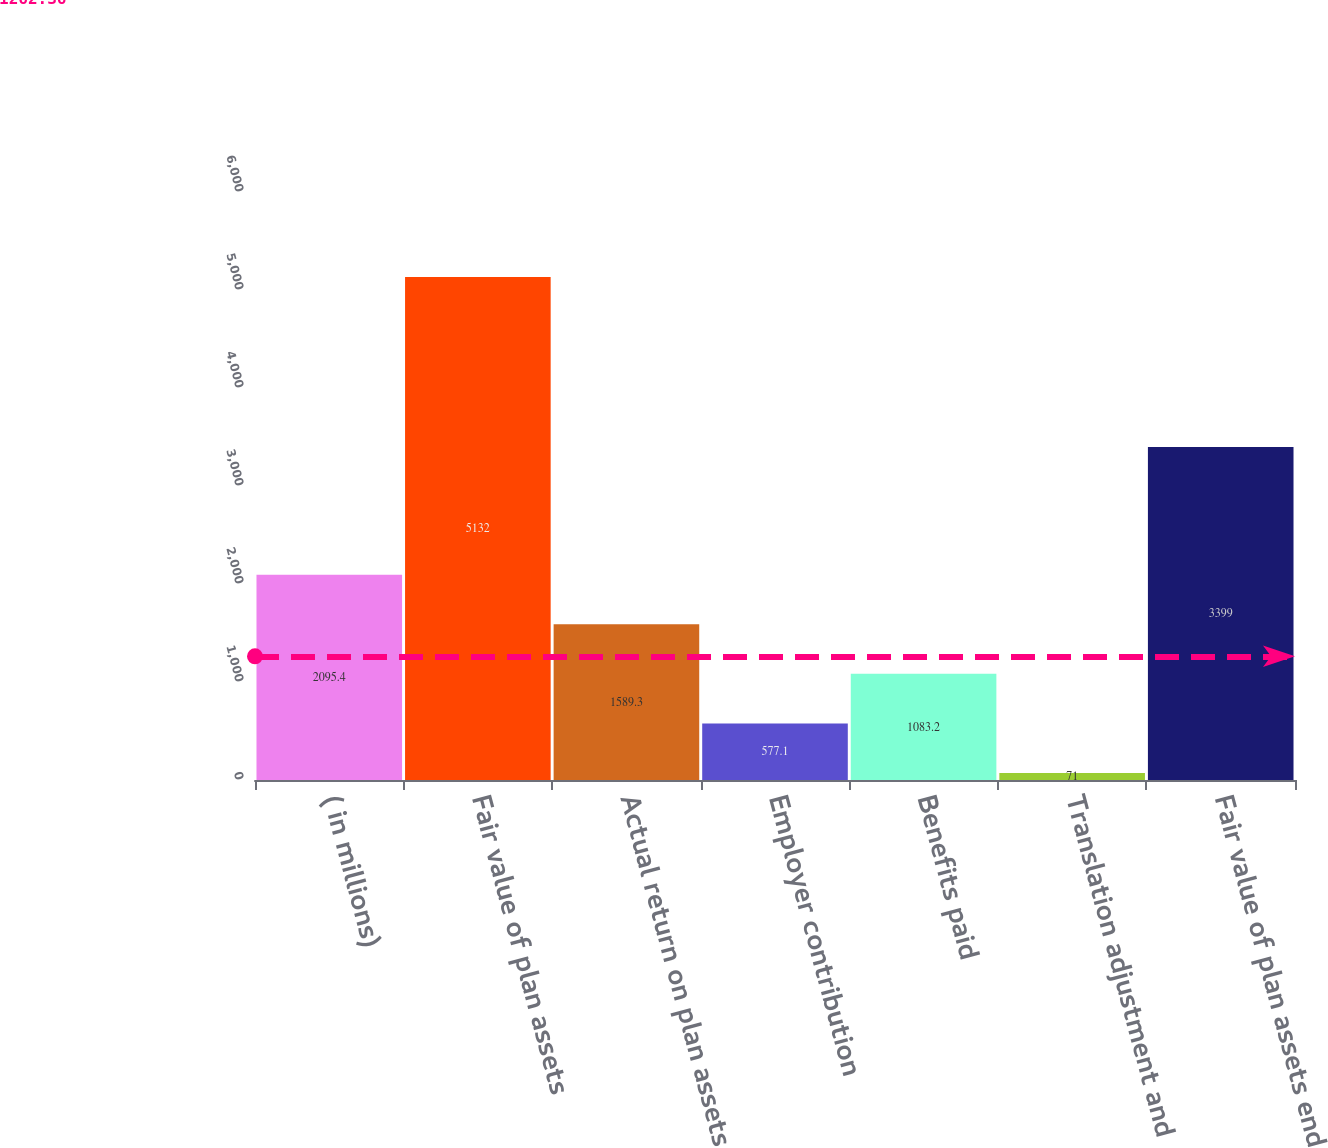Convert chart to OTSL. <chart><loc_0><loc_0><loc_500><loc_500><bar_chart><fcel>( in millions)<fcel>Fair value of plan assets<fcel>Actual return on plan assets<fcel>Employer contribution<fcel>Benefits paid<fcel>Translation adjustment and<fcel>Fair value of plan assets end<nl><fcel>2095.4<fcel>5132<fcel>1589.3<fcel>577.1<fcel>1083.2<fcel>71<fcel>3399<nl></chart> 